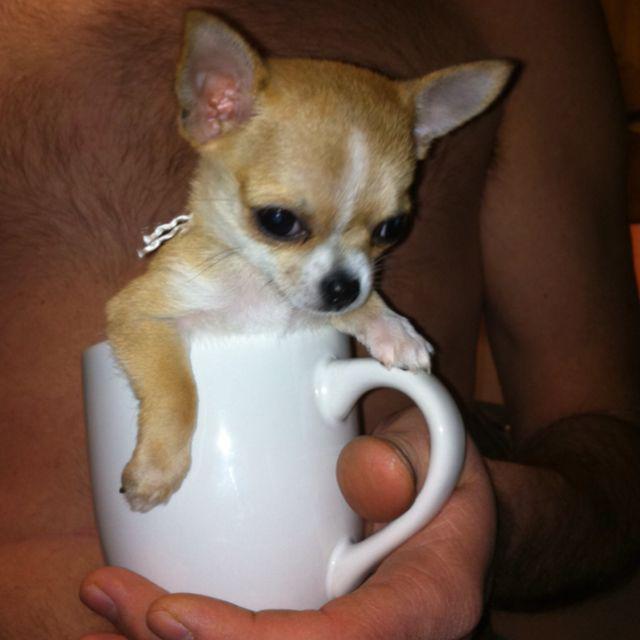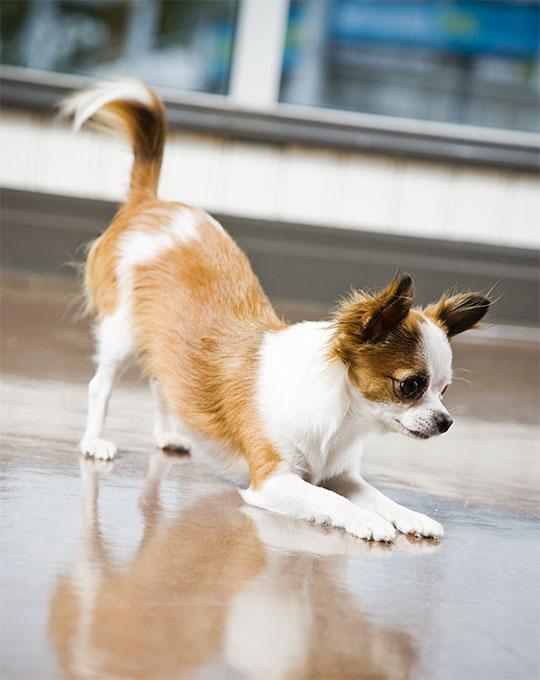The first image is the image on the left, the second image is the image on the right. Examine the images to the left and right. Is the description "A cup is pictured with a chihuahua." accurate? Answer yes or no. Yes. The first image is the image on the left, the second image is the image on the right. Given the left and right images, does the statement "A cup with a handle is pictured with a tiny dog, in one image." hold true? Answer yes or no. Yes. 